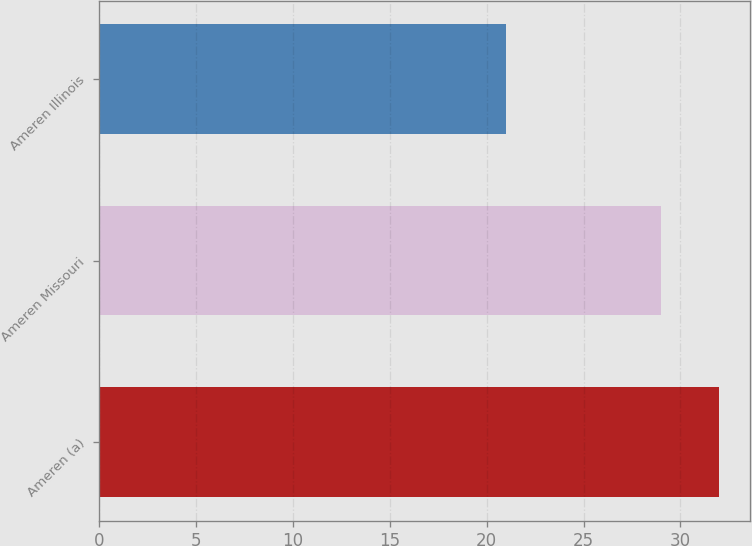Convert chart to OTSL. <chart><loc_0><loc_0><loc_500><loc_500><bar_chart><fcel>Ameren (a)<fcel>Ameren Missouri<fcel>Ameren Illinois<nl><fcel>32<fcel>29<fcel>21<nl></chart> 